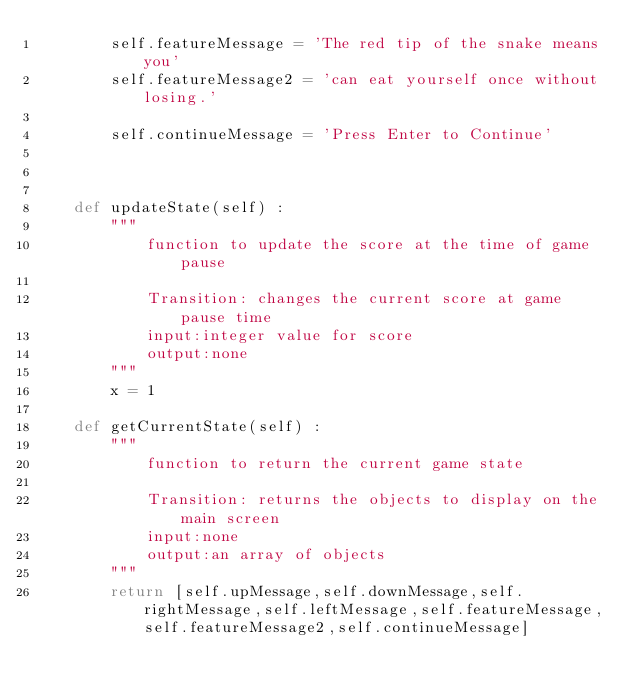Convert code to text. <code><loc_0><loc_0><loc_500><loc_500><_Python_>        self.featureMessage = 'The red tip of the snake means you'
        self.featureMessage2 = 'can eat yourself once without losing.'
        
        self.continueMessage = 'Press Enter to Continue'
        
        
        
    def updateState(self) :
        """
            function to update the score at the time of game pause
            
            Transition: changes the current score at game pause time
            input:integer value for score
            output:none
        """
        x = 1
        
    def getCurrentState(self) :
        """
            function to return the current game state
            
            Transition: returns the objects to display on the main screen
            input:none
            output:an array of objects
        """
        return [self.upMessage,self.downMessage,self.rightMessage,self.leftMessage,self.featureMessage,self.featureMessage2,self.continueMessage]
</code> 